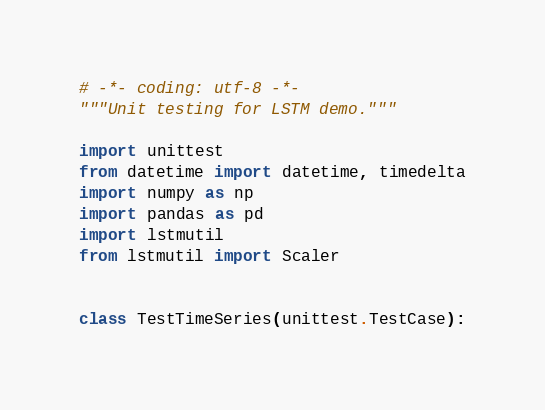Convert code to text. <code><loc_0><loc_0><loc_500><loc_500><_Python_># -*- coding: utf-8 -*-
"""Unit testing for LSTM demo."""

import unittest
from datetime import datetime, timedelta
import numpy as np
import pandas as pd
import lstmutil
from lstmutil import Scaler


class TestTimeSeries(unittest.TestCase):</code> 